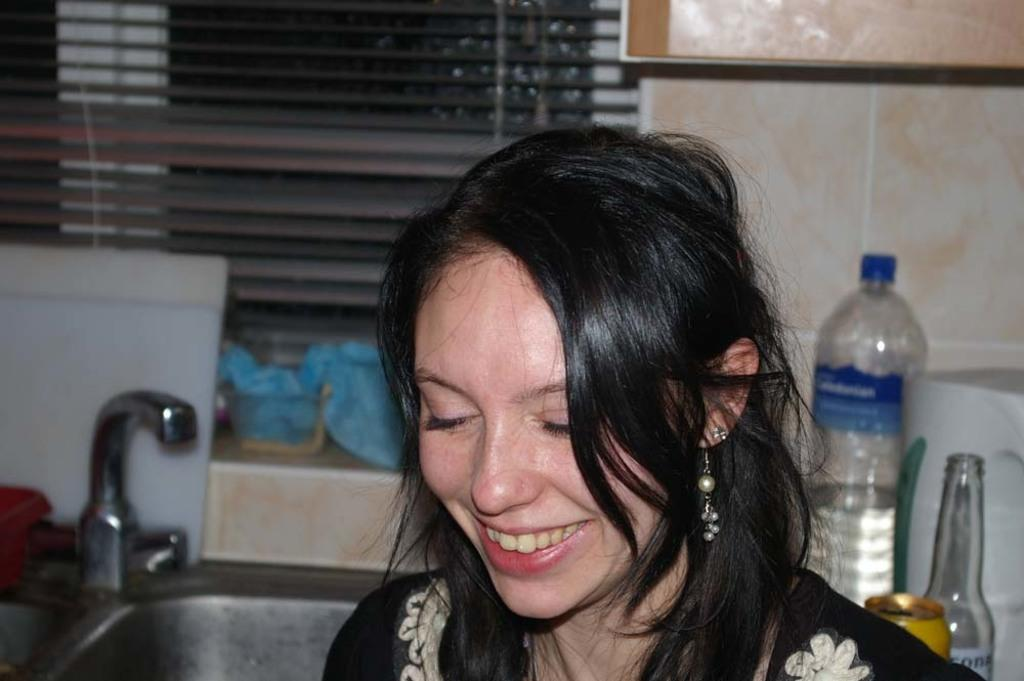Who is present in the image? There is a woman in the image. What is the woman's expression? The woman is smiling. What objects can be seen in the background? There is a bottle, a tin, a tap, a wash basin, and a dome cover in the background. What type of fruit is the woman holding in the image? There is no fruit present in the image; the woman is not holding any fruit. Why is the woman crying in the image? The woman is not crying in the image; she is smiling. 